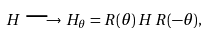Convert formula to latex. <formula><loc_0><loc_0><loc_500><loc_500>H \, \longrightarrow \, H _ { \theta } = R ( \theta ) \, H \, R ( - \theta ) ,</formula> 